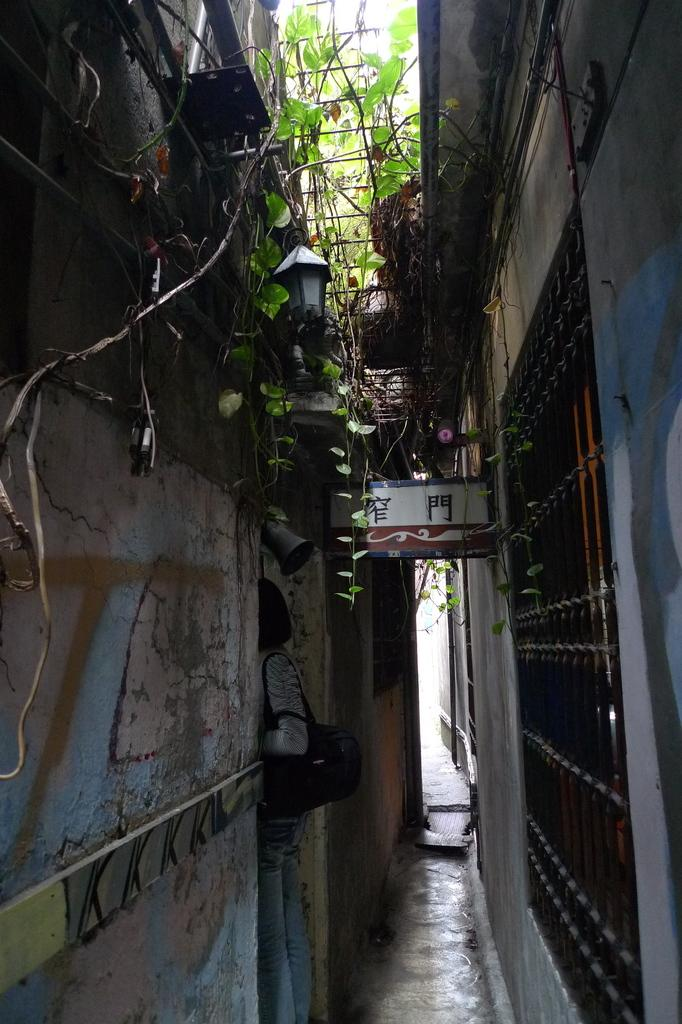What can be seen on both sides of the image? There are buildings on both the right and left sides of the image. What type of vegetation is present in the image? There is a plant in the image. What object can be used for displaying information or advertisements? There is a board in the image. What source of light can be seen in the image? There is a lamp in the image. Where is the net located in the image? There is no net present in the image. What type of market is depicted in the image? There is no market depicted in the image. 